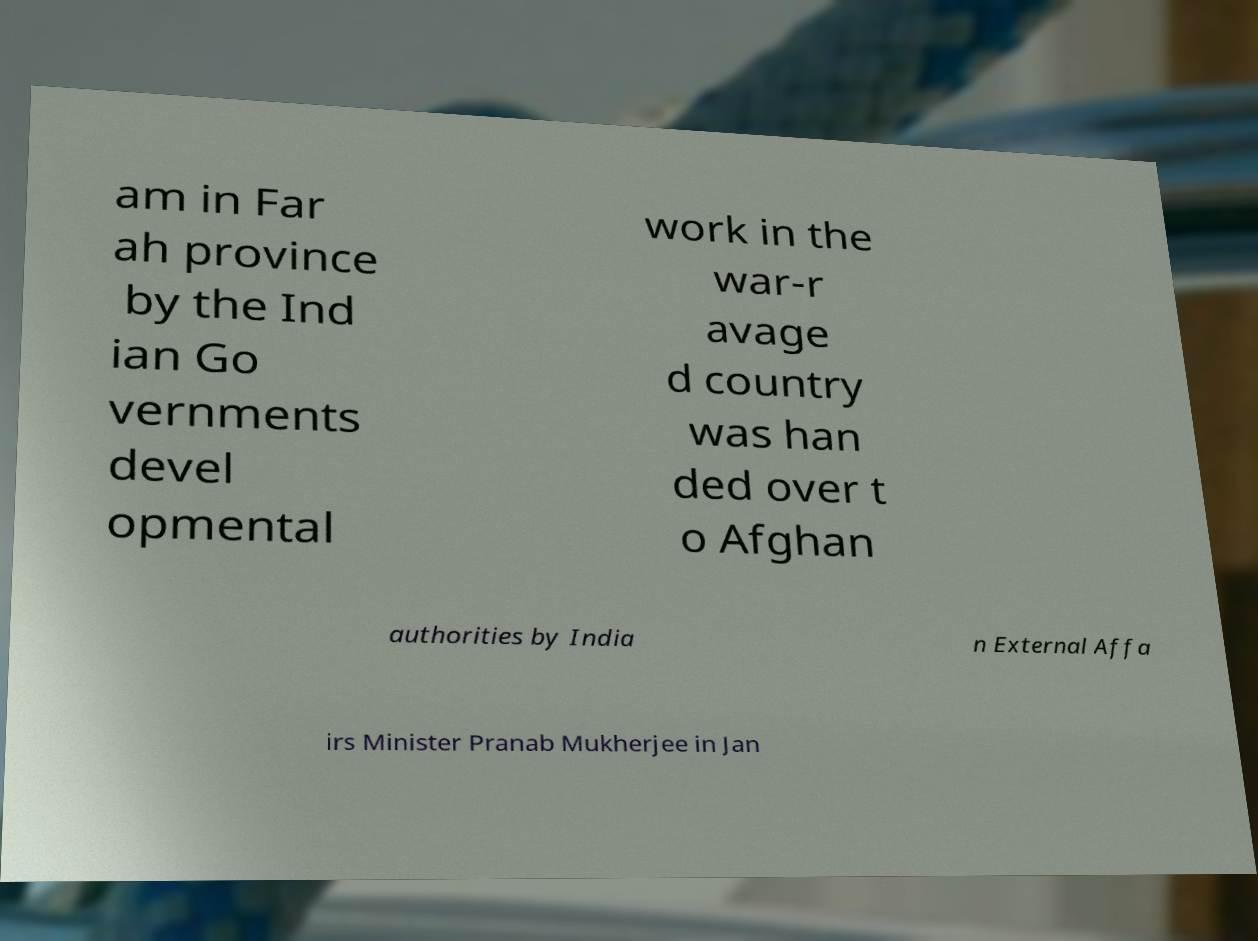Can you accurately transcribe the text from the provided image for me? am in Far ah province by the Ind ian Go vernments devel opmental work in the war-r avage d country was han ded over t o Afghan authorities by India n External Affa irs Minister Pranab Mukherjee in Jan 